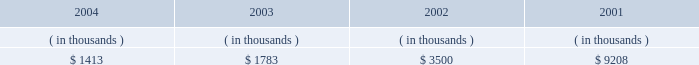Entergy new orleans , inc .
Management's financial discussion and analysis entergy new orleans' receivables from the money pool were as follows as of december 31 for each of the following years: .
Money pool activity provided $ 0.4 million of entergy new orleans' operating cash flow in 2004 , provided $ 1.7 million in 2003 , and provided $ 5.7 million in 2002 .
See note 4 to the domestic utility companies and system energy financial statements for a description of the money pool .
Investing activities net cash used in investing activities decreased $ 15.5 million in 2004 primarily due to capital expenditures related to a turbine inspection project at a fossil plant in 2003 and decreased customer service spending .
Net cash used in investing activities increased $ 23.2 million in 2003 compared to 2002 primarily due to the maturity of $ 14.9 million of other temporary investments in 2002 and increased construction expenditures due to increased customer service spending .
Financing activities net cash used in financing activities increased $ 7.0 million in 2004 primarily due to the costs and expenses related to refinancing $ 75 million of long-term debt in 2004 and an increase of $ 2.2 million in common stock dividends paid .
Net cash used in financing activities increased $ 1.5 million in 2003 primarily due to additional common stock dividends paid of $ 2.2 million .
In july 2003 , entergy new orleans issued $ 30 million of 3.875% ( 3.875 % ) series first mortgage bonds due august 2008 and $ 70 million of 5.25% ( 5.25 % ) series first mortgage bonds due august 2013 .
The proceeds from these issuances were used to redeem , prior to maturity , $ 30 million of 7% ( 7 % ) series first mortgage bonds due july 2008 , $ 40 million of 8% ( 8 % ) series bonds due march 2006 , and $ 30 million of 6.65% ( 6.65 % ) series first mortgage bonds due march 2004 .
The issuances and redemptions are not shown on the cash flow statement because the proceeds from the issuances were placed in a trust for use in the redemptions and never held as cash by entergy new orleans .
See note 5 to the domestic utility companies and system energy financial statements for details on long- term debt .
Uses of capital entergy new orleans requires capital resources for : 2022 construction and other capital investments ; 2022 debt and preferred stock maturities ; 2022 working capital purposes , including the financing of fuel and purchased power costs ; and 2022 dividend and interest payments. .
What the provisions to operating cash flow from money pool as a percentage of receivables from the money pool in 2003? 
Computations: (1.7 / (1783 / 1000))
Answer: 0.95345. Entergy new orleans , inc .
Management's financial discussion and analysis entergy new orleans' receivables from the money pool were as follows as of december 31 for each of the following years: .
Money pool activity provided $ 0.4 million of entergy new orleans' operating cash flow in 2004 , provided $ 1.7 million in 2003 , and provided $ 5.7 million in 2002 .
See note 4 to the domestic utility companies and system energy financial statements for a description of the money pool .
Investing activities net cash used in investing activities decreased $ 15.5 million in 2004 primarily due to capital expenditures related to a turbine inspection project at a fossil plant in 2003 and decreased customer service spending .
Net cash used in investing activities increased $ 23.2 million in 2003 compared to 2002 primarily due to the maturity of $ 14.9 million of other temporary investments in 2002 and increased construction expenditures due to increased customer service spending .
Financing activities net cash used in financing activities increased $ 7.0 million in 2004 primarily due to the costs and expenses related to refinancing $ 75 million of long-term debt in 2004 and an increase of $ 2.2 million in common stock dividends paid .
Net cash used in financing activities increased $ 1.5 million in 2003 primarily due to additional common stock dividends paid of $ 2.2 million .
In july 2003 , entergy new orleans issued $ 30 million of 3.875% ( 3.875 % ) series first mortgage bonds due august 2008 and $ 70 million of 5.25% ( 5.25 % ) series first mortgage bonds due august 2013 .
The proceeds from these issuances were used to redeem , prior to maturity , $ 30 million of 7% ( 7 % ) series first mortgage bonds due july 2008 , $ 40 million of 8% ( 8 % ) series bonds due march 2006 , and $ 30 million of 6.65% ( 6.65 % ) series first mortgage bonds due march 2004 .
The issuances and redemptions are not shown on the cash flow statement because the proceeds from the issuances were placed in a trust for use in the redemptions and never held as cash by entergy new orleans .
See note 5 to the domestic utility companies and system energy financial statements for details on long- term debt .
Uses of capital entergy new orleans requires capital resources for : 2022 construction and other capital investments ; 2022 debt and preferred stock maturities ; 2022 working capital purposes , including the financing of fuel and purchased power costs ; and 2022 dividend and interest payments. .
What is the net cash flow from money pool activity for entergy new orleans' operating cash flow in the last three years? 
Computations: ((0.4 + 1.7) + 5.7)
Answer: 7.8. Entergy new orleans , inc .
Management's financial discussion and analysis entergy new orleans' receivables from the money pool were as follows as of december 31 for each of the following years: .
Money pool activity provided $ 0.4 million of entergy new orleans' operating cash flow in 2004 , provided $ 1.7 million in 2003 , and provided $ 5.7 million in 2002 .
See note 4 to the domestic utility companies and system energy financial statements for a description of the money pool .
Investing activities net cash used in investing activities decreased $ 15.5 million in 2004 primarily due to capital expenditures related to a turbine inspection project at a fossil plant in 2003 and decreased customer service spending .
Net cash used in investing activities increased $ 23.2 million in 2003 compared to 2002 primarily due to the maturity of $ 14.9 million of other temporary investments in 2002 and increased construction expenditures due to increased customer service spending .
Financing activities net cash used in financing activities increased $ 7.0 million in 2004 primarily due to the costs and expenses related to refinancing $ 75 million of long-term debt in 2004 and an increase of $ 2.2 million in common stock dividends paid .
Net cash used in financing activities increased $ 1.5 million in 2003 primarily due to additional common stock dividends paid of $ 2.2 million .
In july 2003 , entergy new orleans issued $ 30 million of 3.875% ( 3.875 % ) series first mortgage bonds due august 2008 and $ 70 million of 5.25% ( 5.25 % ) series first mortgage bonds due august 2013 .
The proceeds from these issuances were used to redeem , prior to maturity , $ 30 million of 7% ( 7 % ) series first mortgage bonds due july 2008 , $ 40 million of 8% ( 8 % ) series bonds due march 2006 , and $ 30 million of 6.65% ( 6.65 % ) series first mortgage bonds due march 2004 .
The issuances and redemptions are not shown on the cash flow statement because the proceeds from the issuances were placed in a trust for use in the redemptions and never held as cash by entergy new orleans .
See note 5 to the domestic utility companies and system energy financial statements for details on long- term debt .
Uses of capital entergy new orleans requires capital resources for : 2022 construction and other capital investments ; 2022 debt and preferred stock maturities ; 2022 working capital purposes , including the financing of fuel and purchased power costs ; and 2022 dividend and interest payments. .
What are the receivables from the money pool as a percentage of additional common stock dividends paid in 2003? 
Computations: ((1783 / 1000) / 2.2)
Answer: 0.81045. 